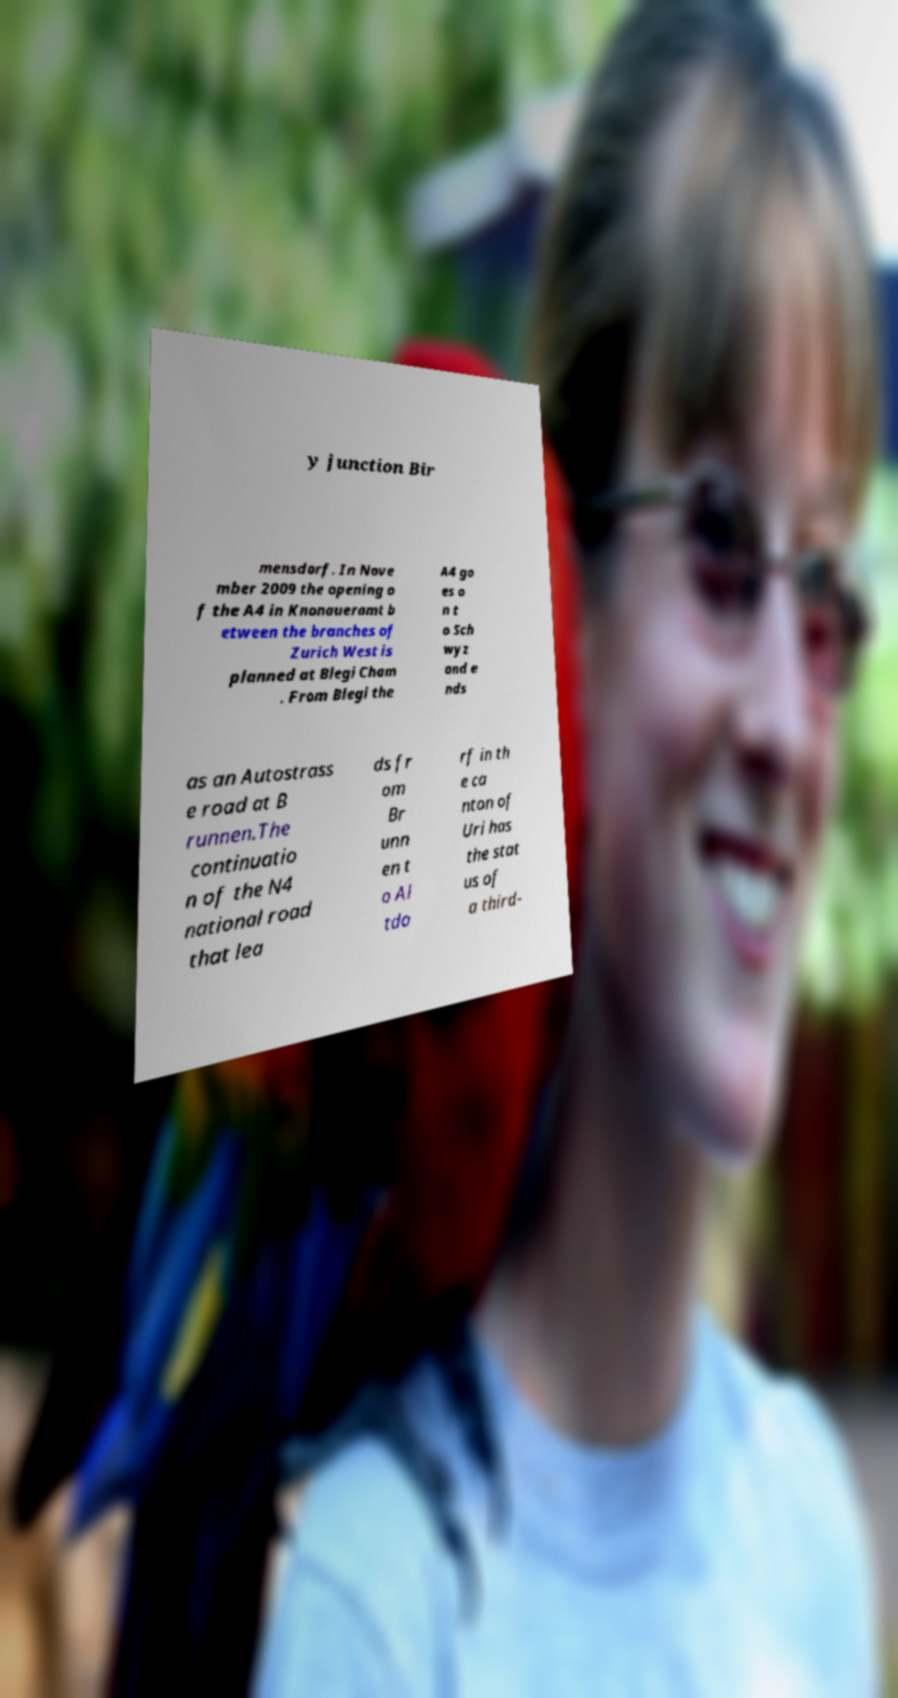Please identify and transcribe the text found in this image. y junction Bir mensdorf. In Nove mber 2009 the opening o f the A4 in Knonaueramt b etween the branches of Zurich West is planned at Blegi Cham . From Blegi the A4 go es o n t o Sch wyz and e nds as an Autostrass e road at B runnen.The continuatio n of the N4 national road that lea ds fr om Br unn en t o Al tdo rf in th e ca nton of Uri has the stat us of a third- 